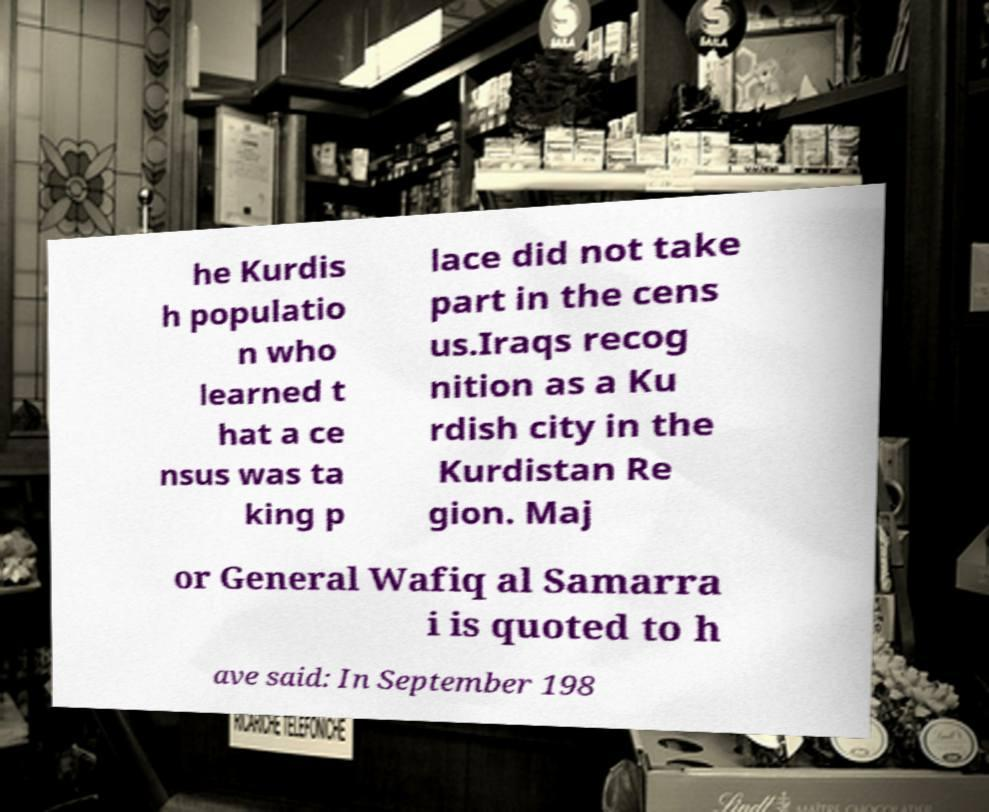Please identify and transcribe the text found in this image. he Kurdis h populatio n who learned t hat a ce nsus was ta king p lace did not take part in the cens us.Iraqs recog nition as a Ku rdish city in the Kurdistan Re gion. Maj or General Wafiq al Samarra i is quoted to h ave said: In September 198 